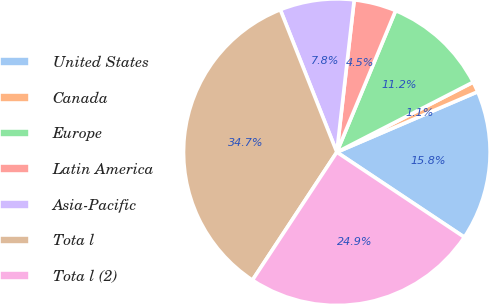Convert chart. <chart><loc_0><loc_0><loc_500><loc_500><pie_chart><fcel>United States<fcel>Canada<fcel>Europe<fcel>Latin America<fcel>Asia-Pacific<fcel>Tota l<fcel>Tota l (2)<nl><fcel>15.81%<fcel>1.1%<fcel>11.18%<fcel>4.46%<fcel>7.82%<fcel>34.71%<fcel>24.92%<nl></chart> 